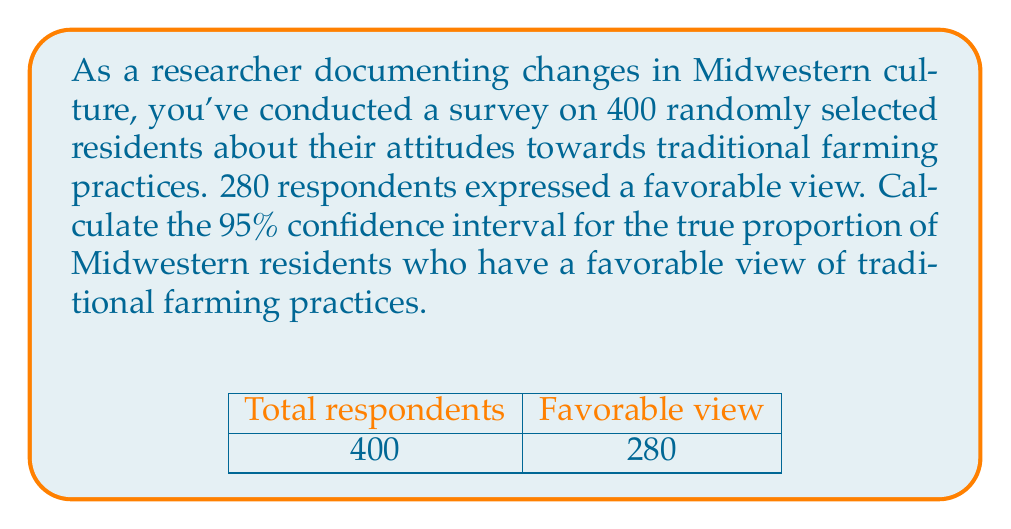Solve this math problem. Let's approach this step-by-step:

1) First, we need to calculate the sample proportion:
   $\hat{p} = \frac{280}{400} = 0.7$

2) For a 95% confidence interval, we use a z-score of 1.96.

3) The formula for the confidence interval is:

   $$\hat{p} \pm z \sqrt{\frac{\hat{p}(1-\hat{p})}{n}}$$

   where $\hat{p}$ is the sample proportion, $z$ is the z-score, and $n$ is the sample size.

4) Let's calculate the margin of error:

   $$\text{Margin of Error} = 1.96 \sqrt{\frac{0.7(1-0.7)}{400}}$$
   $$= 1.96 \sqrt{\frac{0.21}{400}}$$
   $$= 1.96 \sqrt{0.000525}$$
   $$= 1.96 \times 0.0229$$
   $$= 0.0449$$

5) Now we can calculate the confidence interval:

   Lower bound: $0.7 - 0.0449 = 0.6551$
   Upper bound: $0.7 + 0.0449 = 0.7449$

6) Converting to percentages:

   Lower bound: 65.51%
   Upper bound: 74.49%

Therefore, we can say with 95% confidence that the true proportion of Midwestern residents who have a favorable view of traditional farming practices is between 65.51% and 74.49%.
Answer: (65.51%, 74.49%) 